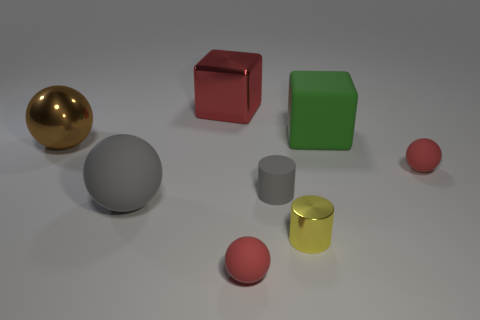Subtract all green spheres. Subtract all gray cubes. How many spheres are left? 4 Add 1 brown spheres. How many objects exist? 9 Subtract all cylinders. How many objects are left? 6 Add 4 big shiny balls. How many big shiny balls are left? 5 Add 2 green metal spheres. How many green metal spheres exist? 2 Subtract 0 brown blocks. How many objects are left? 8 Subtract all large green rubber cubes. Subtract all big green rubber things. How many objects are left? 6 